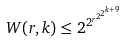<formula> <loc_0><loc_0><loc_500><loc_500>W ( r , k ) \leq 2 ^ { 2 ^ { r ^ { 2 ^ { 2 ^ { k + 9 } } } } }</formula> 